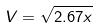<formula> <loc_0><loc_0><loc_500><loc_500>V = \sqrt { 2 . 6 7 x }</formula> 